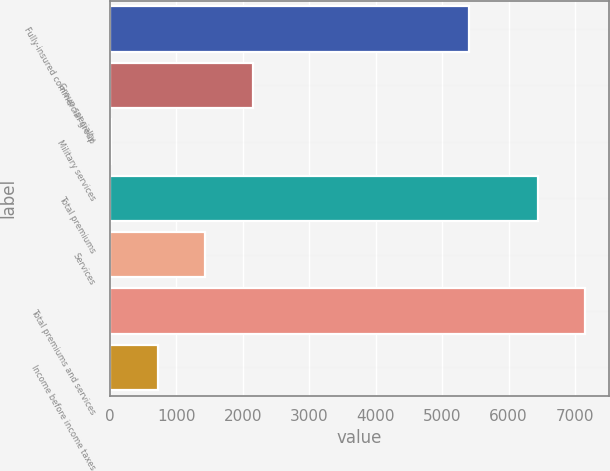Convert chart. <chart><loc_0><loc_0><loc_500><loc_500><bar_chart><fcel>Fully-insured commercial group<fcel>Group specialty<fcel>Military services<fcel>Total premiums<fcel>Services<fcel>Total premiums and services<fcel>Income before income taxes<nl><fcel>5405<fcel>2147.7<fcel>12<fcel>6437<fcel>1435.8<fcel>7148.9<fcel>723.9<nl></chart> 